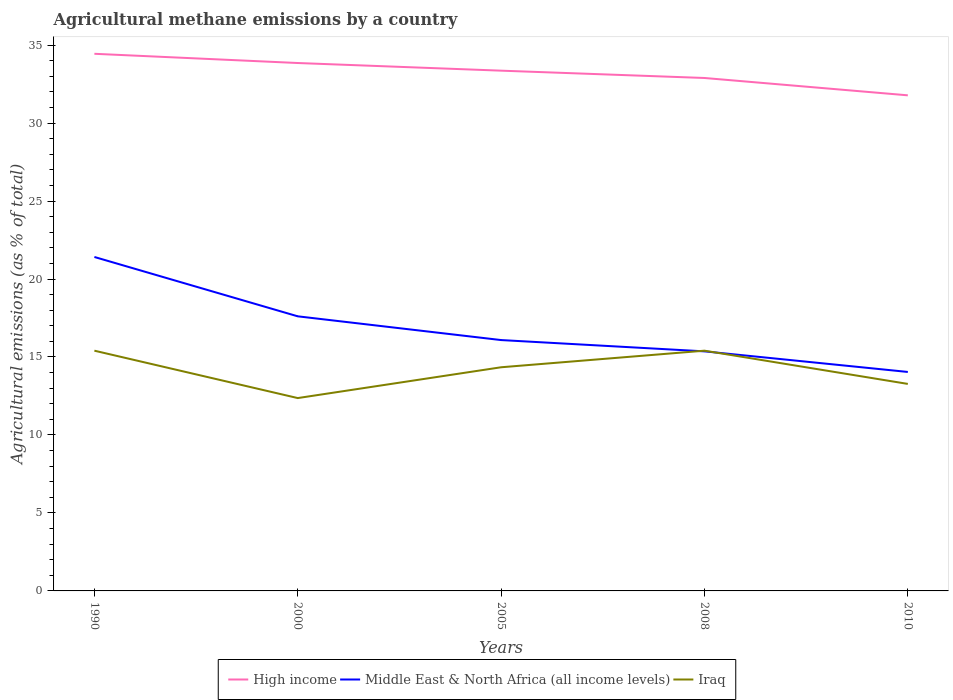Is the number of lines equal to the number of legend labels?
Your response must be concise. Yes. Across all years, what is the maximum amount of agricultural methane emitted in Iraq?
Give a very brief answer. 12.37. What is the total amount of agricultural methane emitted in Iraq in the graph?
Give a very brief answer. -1.98. What is the difference between the highest and the second highest amount of agricultural methane emitted in Iraq?
Your answer should be very brief. 3.04. What is the difference between the highest and the lowest amount of agricultural methane emitted in Iraq?
Provide a succinct answer. 3. How many years are there in the graph?
Give a very brief answer. 5. Are the values on the major ticks of Y-axis written in scientific E-notation?
Offer a very short reply. No. Does the graph contain any zero values?
Your response must be concise. No. Does the graph contain grids?
Make the answer very short. No. Where does the legend appear in the graph?
Your answer should be compact. Bottom center. How are the legend labels stacked?
Offer a terse response. Horizontal. What is the title of the graph?
Offer a very short reply. Agricultural methane emissions by a country. What is the label or title of the X-axis?
Provide a short and direct response. Years. What is the label or title of the Y-axis?
Provide a succinct answer. Agricultural emissions (as % of total). What is the Agricultural emissions (as % of total) in High income in 1990?
Offer a very short reply. 34.44. What is the Agricultural emissions (as % of total) of Middle East & North Africa (all income levels) in 1990?
Ensure brevity in your answer.  21.41. What is the Agricultural emissions (as % of total) in Iraq in 1990?
Keep it short and to the point. 15.4. What is the Agricultural emissions (as % of total) in High income in 2000?
Give a very brief answer. 33.85. What is the Agricultural emissions (as % of total) of Middle East & North Africa (all income levels) in 2000?
Make the answer very short. 17.61. What is the Agricultural emissions (as % of total) of Iraq in 2000?
Give a very brief answer. 12.37. What is the Agricultural emissions (as % of total) of High income in 2005?
Provide a short and direct response. 33.36. What is the Agricultural emissions (as % of total) in Middle East & North Africa (all income levels) in 2005?
Your answer should be compact. 16.09. What is the Agricultural emissions (as % of total) of Iraq in 2005?
Your answer should be compact. 14.34. What is the Agricultural emissions (as % of total) of High income in 2008?
Provide a short and direct response. 32.89. What is the Agricultural emissions (as % of total) in Middle East & North Africa (all income levels) in 2008?
Offer a very short reply. 15.36. What is the Agricultural emissions (as % of total) in Iraq in 2008?
Give a very brief answer. 15.4. What is the Agricultural emissions (as % of total) of High income in 2010?
Your answer should be compact. 31.78. What is the Agricultural emissions (as % of total) in Middle East & North Africa (all income levels) in 2010?
Offer a very short reply. 14.04. What is the Agricultural emissions (as % of total) of Iraq in 2010?
Offer a very short reply. 13.27. Across all years, what is the maximum Agricultural emissions (as % of total) in High income?
Make the answer very short. 34.44. Across all years, what is the maximum Agricultural emissions (as % of total) in Middle East & North Africa (all income levels)?
Offer a terse response. 21.41. Across all years, what is the maximum Agricultural emissions (as % of total) of Iraq?
Your answer should be very brief. 15.4. Across all years, what is the minimum Agricultural emissions (as % of total) of High income?
Your response must be concise. 31.78. Across all years, what is the minimum Agricultural emissions (as % of total) of Middle East & North Africa (all income levels)?
Offer a terse response. 14.04. Across all years, what is the minimum Agricultural emissions (as % of total) of Iraq?
Your answer should be compact. 12.37. What is the total Agricultural emissions (as % of total) of High income in the graph?
Keep it short and to the point. 166.32. What is the total Agricultural emissions (as % of total) of Middle East & North Africa (all income levels) in the graph?
Offer a very short reply. 84.51. What is the total Agricultural emissions (as % of total) of Iraq in the graph?
Make the answer very short. 70.79. What is the difference between the Agricultural emissions (as % of total) of High income in 1990 and that in 2000?
Offer a terse response. 0.59. What is the difference between the Agricultural emissions (as % of total) in Middle East & North Africa (all income levels) in 1990 and that in 2000?
Your response must be concise. 3.81. What is the difference between the Agricultural emissions (as % of total) in Iraq in 1990 and that in 2000?
Provide a short and direct response. 3.04. What is the difference between the Agricultural emissions (as % of total) of High income in 1990 and that in 2005?
Your answer should be very brief. 1.08. What is the difference between the Agricultural emissions (as % of total) in Middle East & North Africa (all income levels) in 1990 and that in 2005?
Your answer should be compact. 5.33. What is the difference between the Agricultural emissions (as % of total) in Iraq in 1990 and that in 2005?
Offer a terse response. 1.06. What is the difference between the Agricultural emissions (as % of total) in High income in 1990 and that in 2008?
Offer a terse response. 1.55. What is the difference between the Agricultural emissions (as % of total) of Middle East & North Africa (all income levels) in 1990 and that in 2008?
Provide a succinct answer. 6.05. What is the difference between the Agricultural emissions (as % of total) of Iraq in 1990 and that in 2008?
Your answer should be compact. 0. What is the difference between the Agricultural emissions (as % of total) in High income in 1990 and that in 2010?
Your answer should be very brief. 2.66. What is the difference between the Agricultural emissions (as % of total) of Middle East & North Africa (all income levels) in 1990 and that in 2010?
Ensure brevity in your answer.  7.37. What is the difference between the Agricultural emissions (as % of total) of Iraq in 1990 and that in 2010?
Provide a short and direct response. 2.13. What is the difference between the Agricultural emissions (as % of total) of High income in 2000 and that in 2005?
Ensure brevity in your answer.  0.49. What is the difference between the Agricultural emissions (as % of total) in Middle East & North Africa (all income levels) in 2000 and that in 2005?
Keep it short and to the point. 1.52. What is the difference between the Agricultural emissions (as % of total) in Iraq in 2000 and that in 2005?
Provide a succinct answer. -1.98. What is the difference between the Agricultural emissions (as % of total) of High income in 2000 and that in 2008?
Your answer should be very brief. 0.96. What is the difference between the Agricultural emissions (as % of total) in Middle East & North Africa (all income levels) in 2000 and that in 2008?
Your answer should be compact. 2.25. What is the difference between the Agricultural emissions (as % of total) of Iraq in 2000 and that in 2008?
Make the answer very short. -3.04. What is the difference between the Agricultural emissions (as % of total) in High income in 2000 and that in 2010?
Provide a succinct answer. 2.07. What is the difference between the Agricultural emissions (as % of total) in Middle East & North Africa (all income levels) in 2000 and that in 2010?
Provide a short and direct response. 3.57. What is the difference between the Agricultural emissions (as % of total) in Iraq in 2000 and that in 2010?
Ensure brevity in your answer.  -0.91. What is the difference between the Agricultural emissions (as % of total) of High income in 2005 and that in 2008?
Your answer should be very brief. 0.47. What is the difference between the Agricultural emissions (as % of total) of Middle East & North Africa (all income levels) in 2005 and that in 2008?
Offer a very short reply. 0.72. What is the difference between the Agricultural emissions (as % of total) of Iraq in 2005 and that in 2008?
Give a very brief answer. -1.06. What is the difference between the Agricultural emissions (as % of total) in High income in 2005 and that in 2010?
Keep it short and to the point. 1.58. What is the difference between the Agricultural emissions (as % of total) of Middle East & North Africa (all income levels) in 2005 and that in 2010?
Provide a short and direct response. 2.05. What is the difference between the Agricultural emissions (as % of total) of Iraq in 2005 and that in 2010?
Give a very brief answer. 1.07. What is the difference between the Agricultural emissions (as % of total) in High income in 2008 and that in 2010?
Offer a terse response. 1.11. What is the difference between the Agricultural emissions (as % of total) of Middle East & North Africa (all income levels) in 2008 and that in 2010?
Offer a terse response. 1.32. What is the difference between the Agricultural emissions (as % of total) in Iraq in 2008 and that in 2010?
Provide a short and direct response. 2.13. What is the difference between the Agricultural emissions (as % of total) in High income in 1990 and the Agricultural emissions (as % of total) in Middle East & North Africa (all income levels) in 2000?
Keep it short and to the point. 16.83. What is the difference between the Agricultural emissions (as % of total) in High income in 1990 and the Agricultural emissions (as % of total) in Iraq in 2000?
Provide a short and direct response. 22.08. What is the difference between the Agricultural emissions (as % of total) in Middle East & North Africa (all income levels) in 1990 and the Agricultural emissions (as % of total) in Iraq in 2000?
Make the answer very short. 9.05. What is the difference between the Agricultural emissions (as % of total) of High income in 1990 and the Agricultural emissions (as % of total) of Middle East & North Africa (all income levels) in 2005?
Offer a very short reply. 18.36. What is the difference between the Agricultural emissions (as % of total) of High income in 1990 and the Agricultural emissions (as % of total) of Iraq in 2005?
Keep it short and to the point. 20.1. What is the difference between the Agricultural emissions (as % of total) of Middle East & North Africa (all income levels) in 1990 and the Agricultural emissions (as % of total) of Iraq in 2005?
Ensure brevity in your answer.  7.07. What is the difference between the Agricultural emissions (as % of total) in High income in 1990 and the Agricultural emissions (as % of total) in Middle East & North Africa (all income levels) in 2008?
Give a very brief answer. 19.08. What is the difference between the Agricultural emissions (as % of total) in High income in 1990 and the Agricultural emissions (as % of total) in Iraq in 2008?
Your answer should be compact. 19.04. What is the difference between the Agricultural emissions (as % of total) of Middle East & North Africa (all income levels) in 1990 and the Agricultural emissions (as % of total) of Iraq in 2008?
Provide a succinct answer. 6.01. What is the difference between the Agricultural emissions (as % of total) in High income in 1990 and the Agricultural emissions (as % of total) in Middle East & North Africa (all income levels) in 2010?
Provide a short and direct response. 20.4. What is the difference between the Agricultural emissions (as % of total) of High income in 1990 and the Agricultural emissions (as % of total) of Iraq in 2010?
Ensure brevity in your answer.  21.17. What is the difference between the Agricultural emissions (as % of total) in Middle East & North Africa (all income levels) in 1990 and the Agricultural emissions (as % of total) in Iraq in 2010?
Your answer should be very brief. 8.14. What is the difference between the Agricultural emissions (as % of total) in High income in 2000 and the Agricultural emissions (as % of total) in Middle East & North Africa (all income levels) in 2005?
Keep it short and to the point. 17.77. What is the difference between the Agricultural emissions (as % of total) of High income in 2000 and the Agricultural emissions (as % of total) of Iraq in 2005?
Provide a succinct answer. 19.51. What is the difference between the Agricultural emissions (as % of total) of Middle East & North Africa (all income levels) in 2000 and the Agricultural emissions (as % of total) of Iraq in 2005?
Ensure brevity in your answer.  3.27. What is the difference between the Agricultural emissions (as % of total) in High income in 2000 and the Agricultural emissions (as % of total) in Middle East & North Africa (all income levels) in 2008?
Provide a short and direct response. 18.49. What is the difference between the Agricultural emissions (as % of total) in High income in 2000 and the Agricultural emissions (as % of total) in Iraq in 2008?
Provide a short and direct response. 18.45. What is the difference between the Agricultural emissions (as % of total) of Middle East & North Africa (all income levels) in 2000 and the Agricultural emissions (as % of total) of Iraq in 2008?
Your answer should be very brief. 2.2. What is the difference between the Agricultural emissions (as % of total) in High income in 2000 and the Agricultural emissions (as % of total) in Middle East & North Africa (all income levels) in 2010?
Provide a succinct answer. 19.81. What is the difference between the Agricultural emissions (as % of total) of High income in 2000 and the Agricultural emissions (as % of total) of Iraq in 2010?
Keep it short and to the point. 20.58. What is the difference between the Agricultural emissions (as % of total) of Middle East & North Africa (all income levels) in 2000 and the Agricultural emissions (as % of total) of Iraq in 2010?
Ensure brevity in your answer.  4.33. What is the difference between the Agricultural emissions (as % of total) in High income in 2005 and the Agricultural emissions (as % of total) in Middle East & North Africa (all income levels) in 2008?
Provide a short and direct response. 18. What is the difference between the Agricultural emissions (as % of total) in High income in 2005 and the Agricultural emissions (as % of total) in Iraq in 2008?
Provide a succinct answer. 17.96. What is the difference between the Agricultural emissions (as % of total) of Middle East & North Africa (all income levels) in 2005 and the Agricultural emissions (as % of total) of Iraq in 2008?
Your response must be concise. 0.68. What is the difference between the Agricultural emissions (as % of total) of High income in 2005 and the Agricultural emissions (as % of total) of Middle East & North Africa (all income levels) in 2010?
Offer a terse response. 19.32. What is the difference between the Agricultural emissions (as % of total) of High income in 2005 and the Agricultural emissions (as % of total) of Iraq in 2010?
Ensure brevity in your answer.  20.09. What is the difference between the Agricultural emissions (as % of total) in Middle East & North Africa (all income levels) in 2005 and the Agricultural emissions (as % of total) in Iraq in 2010?
Make the answer very short. 2.81. What is the difference between the Agricultural emissions (as % of total) of High income in 2008 and the Agricultural emissions (as % of total) of Middle East & North Africa (all income levels) in 2010?
Offer a terse response. 18.85. What is the difference between the Agricultural emissions (as % of total) in High income in 2008 and the Agricultural emissions (as % of total) in Iraq in 2010?
Ensure brevity in your answer.  19.62. What is the difference between the Agricultural emissions (as % of total) in Middle East & North Africa (all income levels) in 2008 and the Agricultural emissions (as % of total) in Iraq in 2010?
Provide a succinct answer. 2.09. What is the average Agricultural emissions (as % of total) of High income per year?
Make the answer very short. 33.26. What is the average Agricultural emissions (as % of total) in Middle East & North Africa (all income levels) per year?
Make the answer very short. 16.9. What is the average Agricultural emissions (as % of total) of Iraq per year?
Give a very brief answer. 14.16. In the year 1990, what is the difference between the Agricultural emissions (as % of total) in High income and Agricultural emissions (as % of total) in Middle East & North Africa (all income levels)?
Keep it short and to the point. 13.03. In the year 1990, what is the difference between the Agricultural emissions (as % of total) of High income and Agricultural emissions (as % of total) of Iraq?
Offer a terse response. 19.04. In the year 1990, what is the difference between the Agricultural emissions (as % of total) in Middle East & North Africa (all income levels) and Agricultural emissions (as % of total) in Iraq?
Offer a very short reply. 6.01. In the year 2000, what is the difference between the Agricultural emissions (as % of total) of High income and Agricultural emissions (as % of total) of Middle East & North Africa (all income levels)?
Offer a terse response. 16.24. In the year 2000, what is the difference between the Agricultural emissions (as % of total) in High income and Agricultural emissions (as % of total) in Iraq?
Provide a succinct answer. 21.48. In the year 2000, what is the difference between the Agricultural emissions (as % of total) in Middle East & North Africa (all income levels) and Agricultural emissions (as % of total) in Iraq?
Provide a short and direct response. 5.24. In the year 2005, what is the difference between the Agricultural emissions (as % of total) of High income and Agricultural emissions (as % of total) of Middle East & North Africa (all income levels)?
Give a very brief answer. 17.27. In the year 2005, what is the difference between the Agricultural emissions (as % of total) of High income and Agricultural emissions (as % of total) of Iraq?
Ensure brevity in your answer.  19.02. In the year 2005, what is the difference between the Agricultural emissions (as % of total) of Middle East & North Africa (all income levels) and Agricultural emissions (as % of total) of Iraq?
Offer a very short reply. 1.74. In the year 2008, what is the difference between the Agricultural emissions (as % of total) in High income and Agricultural emissions (as % of total) in Middle East & North Africa (all income levels)?
Your answer should be very brief. 17.53. In the year 2008, what is the difference between the Agricultural emissions (as % of total) of High income and Agricultural emissions (as % of total) of Iraq?
Offer a terse response. 17.49. In the year 2008, what is the difference between the Agricultural emissions (as % of total) in Middle East & North Africa (all income levels) and Agricultural emissions (as % of total) in Iraq?
Offer a terse response. -0.04. In the year 2010, what is the difference between the Agricultural emissions (as % of total) in High income and Agricultural emissions (as % of total) in Middle East & North Africa (all income levels)?
Offer a very short reply. 17.74. In the year 2010, what is the difference between the Agricultural emissions (as % of total) of High income and Agricultural emissions (as % of total) of Iraq?
Provide a succinct answer. 18.5. In the year 2010, what is the difference between the Agricultural emissions (as % of total) in Middle East & North Africa (all income levels) and Agricultural emissions (as % of total) in Iraq?
Give a very brief answer. 0.77. What is the ratio of the Agricultural emissions (as % of total) of High income in 1990 to that in 2000?
Give a very brief answer. 1.02. What is the ratio of the Agricultural emissions (as % of total) of Middle East & North Africa (all income levels) in 1990 to that in 2000?
Your response must be concise. 1.22. What is the ratio of the Agricultural emissions (as % of total) of Iraq in 1990 to that in 2000?
Offer a terse response. 1.25. What is the ratio of the Agricultural emissions (as % of total) of High income in 1990 to that in 2005?
Your answer should be very brief. 1.03. What is the ratio of the Agricultural emissions (as % of total) of Middle East & North Africa (all income levels) in 1990 to that in 2005?
Your answer should be very brief. 1.33. What is the ratio of the Agricultural emissions (as % of total) of Iraq in 1990 to that in 2005?
Your answer should be compact. 1.07. What is the ratio of the Agricultural emissions (as % of total) of High income in 1990 to that in 2008?
Offer a terse response. 1.05. What is the ratio of the Agricultural emissions (as % of total) in Middle East & North Africa (all income levels) in 1990 to that in 2008?
Provide a short and direct response. 1.39. What is the ratio of the Agricultural emissions (as % of total) of High income in 1990 to that in 2010?
Keep it short and to the point. 1.08. What is the ratio of the Agricultural emissions (as % of total) of Middle East & North Africa (all income levels) in 1990 to that in 2010?
Offer a very short reply. 1.53. What is the ratio of the Agricultural emissions (as % of total) of Iraq in 1990 to that in 2010?
Offer a terse response. 1.16. What is the ratio of the Agricultural emissions (as % of total) in High income in 2000 to that in 2005?
Ensure brevity in your answer.  1.01. What is the ratio of the Agricultural emissions (as % of total) of Middle East & North Africa (all income levels) in 2000 to that in 2005?
Offer a terse response. 1.09. What is the ratio of the Agricultural emissions (as % of total) of Iraq in 2000 to that in 2005?
Your response must be concise. 0.86. What is the ratio of the Agricultural emissions (as % of total) in High income in 2000 to that in 2008?
Give a very brief answer. 1.03. What is the ratio of the Agricultural emissions (as % of total) in Middle East & North Africa (all income levels) in 2000 to that in 2008?
Provide a succinct answer. 1.15. What is the ratio of the Agricultural emissions (as % of total) in Iraq in 2000 to that in 2008?
Provide a short and direct response. 0.8. What is the ratio of the Agricultural emissions (as % of total) of High income in 2000 to that in 2010?
Provide a succinct answer. 1.07. What is the ratio of the Agricultural emissions (as % of total) of Middle East & North Africa (all income levels) in 2000 to that in 2010?
Offer a very short reply. 1.25. What is the ratio of the Agricultural emissions (as % of total) in Iraq in 2000 to that in 2010?
Your answer should be very brief. 0.93. What is the ratio of the Agricultural emissions (as % of total) of High income in 2005 to that in 2008?
Ensure brevity in your answer.  1.01. What is the ratio of the Agricultural emissions (as % of total) of Middle East & North Africa (all income levels) in 2005 to that in 2008?
Provide a succinct answer. 1.05. What is the ratio of the Agricultural emissions (as % of total) of Iraq in 2005 to that in 2008?
Your answer should be very brief. 0.93. What is the ratio of the Agricultural emissions (as % of total) of High income in 2005 to that in 2010?
Offer a terse response. 1.05. What is the ratio of the Agricultural emissions (as % of total) in Middle East & North Africa (all income levels) in 2005 to that in 2010?
Offer a very short reply. 1.15. What is the ratio of the Agricultural emissions (as % of total) in Iraq in 2005 to that in 2010?
Offer a very short reply. 1.08. What is the ratio of the Agricultural emissions (as % of total) in High income in 2008 to that in 2010?
Offer a terse response. 1.03. What is the ratio of the Agricultural emissions (as % of total) of Middle East & North Africa (all income levels) in 2008 to that in 2010?
Offer a very short reply. 1.09. What is the ratio of the Agricultural emissions (as % of total) in Iraq in 2008 to that in 2010?
Make the answer very short. 1.16. What is the difference between the highest and the second highest Agricultural emissions (as % of total) in High income?
Make the answer very short. 0.59. What is the difference between the highest and the second highest Agricultural emissions (as % of total) in Middle East & North Africa (all income levels)?
Ensure brevity in your answer.  3.81. What is the difference between the highest and the second highest Agricultural emissions (as % of total) of Iraq?
Offer a terse response. 0. What is the difference between the highest and the lowest Agricultural emissions (as % of total) in High income?
Offer a terse response. 2.66. What is the difference between the highest and the lowest Agricultural emissions (as % of total) in Middle East & North Africa (all income levels)?
Keep it short and to the point. 7.37. What is the difference between the highest and the lowest Agricultural emissions (as % of total) in Iraq?
Provide a short and direct response. 3.04. 